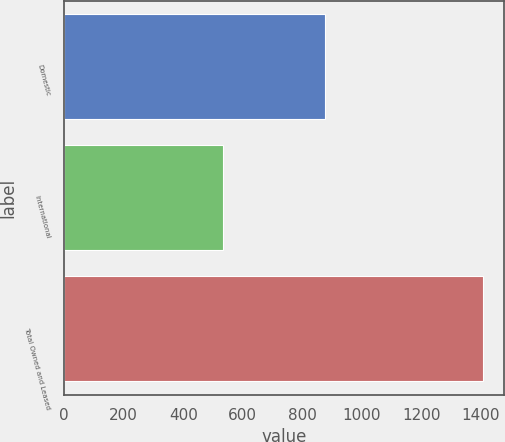Convert chart to OTSL. <chart><loc_0><loc_0><loc_500><loc_500><bar_chart><fcel>Domestic<fcel>International<fcel>Total Owned and Leased<nl><fcel>876<fcel>533<fcel>1409<nl></chart> 